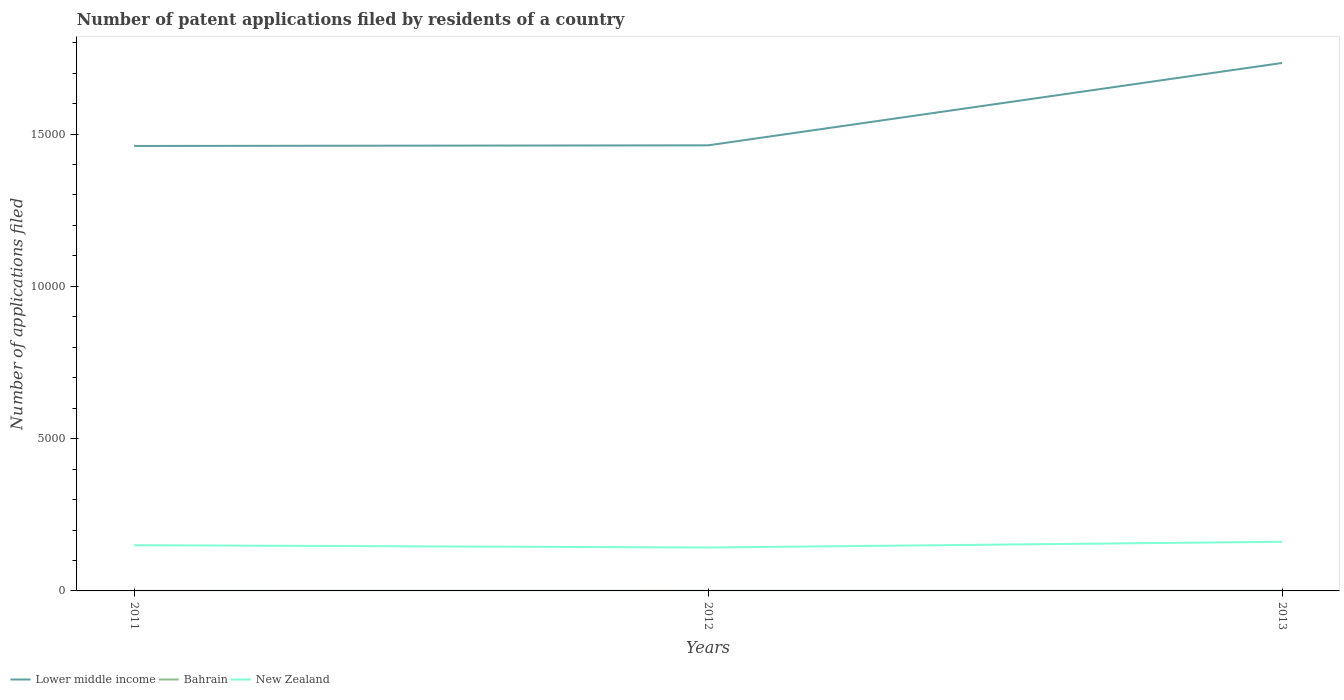Is the number of lines equal to the number of legend labels?
Provide a short and direct response. Yes. Across all years, what is the maximum number of applications filed in Bahrain?
Give a very brief answer. 1. In which year was the number of applications filed in New Zealand maximum?
Ensure brevity in your answer.  2012. What is the total number of applications filed in Lower middle income in the graph?
Your answer should be compact. -2704. What is the difference between the highest and the second highest number of applications filed in Lower middle income?
Offer a terse response. 2725. How many lines are there?
Offer a very short reply. 3. How many years are there in the graph?
Provide a short and direct response. 3. What is the difference between two consecutive major ticks on the Y-axis?
Your answer should be very brief. 5000. Are the values on the major ticks of Y-axis written in scientific E-notation?
Provide a short and direct response. No. Where does the legend appear in the graph?
Provide a succinct answer. Bottom left. How many legend labels are there?
Your answer should be compact. 3. What is the title of the graph?
Give a very brief answer. Number of patent applications filed by residents of a country. What is the label or title of the Y-axis?
Ensure brevity in your answer.  Number of applications filed. What is the Number of applications filed of Lower middle income in 2011?
Your answer should be very brief. 1.46e+04. What is the Number of applications filed of New Zealand in 2011?
Your answer should be compact. 1501. What is the Number of applications filed of Lower middle income in 2012?
Make the answer very short. 1.46e+04. What is the Number of applications filed of New Zealand in 2012?
Offer a terse response. 1425. What is the Number of applications filed of Lower middle income in 2013?
Your answer should be very brief. 1.73e+04. What is the Number of applications filed in Bahrain in 2013?
Provide a succinct answer. 3. What is the Number of applications filed in New Zealand in 2013?
Give a very brief answer. 1614. Across all years, what is the maximum Number of applications filed of Lower middle income?
Give a very brief answer. 1.73e+04. Across all years, what is the maximum Number of applications filed of Bahrain?
Give a very brief answer. 3. Across all years, what is the maximum Number of applications filed in New Zealand?
Your answer should be compact. 1614. Across all years, what is the minimum Number of applications filed of Lower middle income?
Offer a terse response. 1.46e+04. Across all years, what is the minimum Number of applications filed in Bahrain?
Make the answer very short. 1. Across all years, what is the minimum Number of applications filed in New Zealand?
Make the answer very short. 1425. What is the total Number of applications filed of Lower middle income in the graph?
Give a very brief answer. 4.66e+04. What is the total Number of applications filed of New Zealand in the graph?
Give a very brief answer. 4540. What is the difference between the Number of applications filed of Lower middle income in 2011 and that in 2012?
Make the answer very short. -21. What is the difference between the Number of applications filed of Lower middle income in 2011 and that in 2013?
Your answer should be very brief. -2725. What is the difference between the Number of applications filed of New Zealand in 2011 and that in 2013?
Your answer should be very brief. -113. What is the difference between the Number of applications filed of Lower middle income in 2012 and that in 2013?
Ensure brevity in your answer.  -2704. What is the difference between the Number of applications filed of Bahrain in 2012 and that in 2013?
Offer a terse response. 0. What is the difference between the Number of applications filed of New Zealand in 2012 and that in 2013?
Keep it short and to the point. -189. What is the difference between the Number of applications filed in Lower middle income in 2011 and the Number of applications filed in Bahrain in 2012?
Ensure brevity in your answer.  1.46e+04. What is the difference between the Number of applications filed of Lower middle income in 2011 and the Number of applications filed of New Zealand in 2012?
Provide a short and direct response. 1.32e+04. What is the difference between the Number of applications filed in Bahrain in 2011 and the Number of applications filed in New Zealand in 2012?
Your answer should be very brief. -1424. What is the difference between the Number of applications filed in Lower middle income in 2011 and the Number of applications filed in Bahrain in 2013?
Offer a very short reply. 1.46e+04. What is the difference between the Number of applications filed in Lower middle income in 2011 and the Number of applications filed in New Zealand in 2013?
Provide a succinct answer. 1.30e+04. What is the difference between the Number of applications filed in Bahrain in 2011 and the Number of applications filed in New Zealand in 2013?
Provide a succinct answer. -1613. What is the difference between the Number of applications filed of Lower middle income in 2012 and the Number of applications filed of Bahrain in 2013?
Give a very brief answer. 1.46e+04. What is the difference between the Number of applications filed in Lower middle income in 2012 and the Number of applications filed in New Zealand in 2013?
Your response must be concise. 1.30e+04. What is the difference between the Number of applications filed of Bahrain in 2012 and the Number of applications filed of New Zealand in 2013?
Provide a short and direct response. -1611. What is the average Number of applications filed in Lower middle income per year?
Make the answer very short. 1.55e+04. What is the average Number of applications filed in Bahrain per year?
Keep it short and to the point. 2.33. What is the average Number of applications filed of New Zealand per year?
Ensure brevity in your answer.  1513.33. In the year 2011, what is the difference between the Number of applications filed of Lower middle income and Number of applications filed of Bahrain?
Ensure brevity in your answer.  1.46e+04. In the year 2011, what is the difference between the Number of applications filed in Lower middle income and Number of applications filed in New Zealand?
Offer a very short reply. 1.31e+04. In the year 2011, what is the difference between the Number of applications filed of Bahrain and Number of applications filed of New Zealand?
Provide a short and direct response. -1500. In the year 2012, what is the difference between the Number of applications filed in Lower middle income and Number of applications filed in Bahrain?
Provide a short and direct response. 1.46e+04. In the year 2012, what is the difference between the Number of applications filed of Lower middle income and Number of applications filed of New Zealand?
Provide a short and direct response. 1.32e+04. In the year 2012, what is the difference between the Number of applications filed of Bahrain and Number of applications filed of New Zealand?
Offer a very short reply. -1422. In the year 2013, what is the difference between the Number of applications filed in Lower middle income and Number of applications filed in Bahrain?
Provide a succinct answer. 1.73e+04. In the year 2013, what is the difference between the Number of applications filed in Lower middle income and Number of applications filed in New Zealand?
Give a very brief answer. 1.57e+04. In the year 2013, what is the difference between the Number of applications filed in Bahrain and Number of applications filed in New Zealand?
Your answer should be very brief. -1611. What is the ratio of the Number of applications filed in Bahrain in 2011 to that in 2012?
Offer a terse response. 0.33. What is the ratio of the Number of applications filed in New Zealand in 2011 to that in 2012?
Your answer should be very brief. 1.05. What is the ratio of the Number of applications filed of Lower middle income in 2011 to that in 2013?
Make the answer very short. 0.84. What is the ratio of the Number of applications filed of Lower middle income in 2012 to that in 2013?
Offer a very short reply. 0.84. What is the ratio of the Number of applications filed of New Zealand in 2012 to that in 2013?
Your answer should be compact. 0.88. What is the difference between the highest and the second highest Number of applications filed of Lower middle income?
Provide a short and direct response. 2704. What is the difference between the highest and the second highest Number of applications filed in New Zealand?
Offer a very short reply. 113. What is the difference between the highest and the lowest Number of applications filed in Lower middle income?
Give a very brief answer. 2725. What is the difference between the highest and the lowest Number of applications filed in New Zealand?
Provide a succinct answer. 189. 